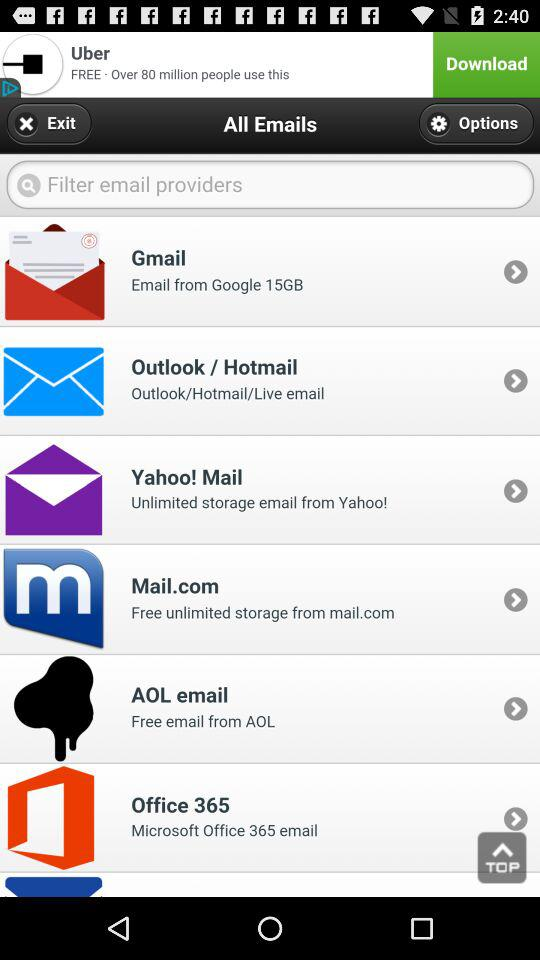How much does Mail.com storage cost?
When the provided information is insufficient, respond with <no answer>. <no answer> 